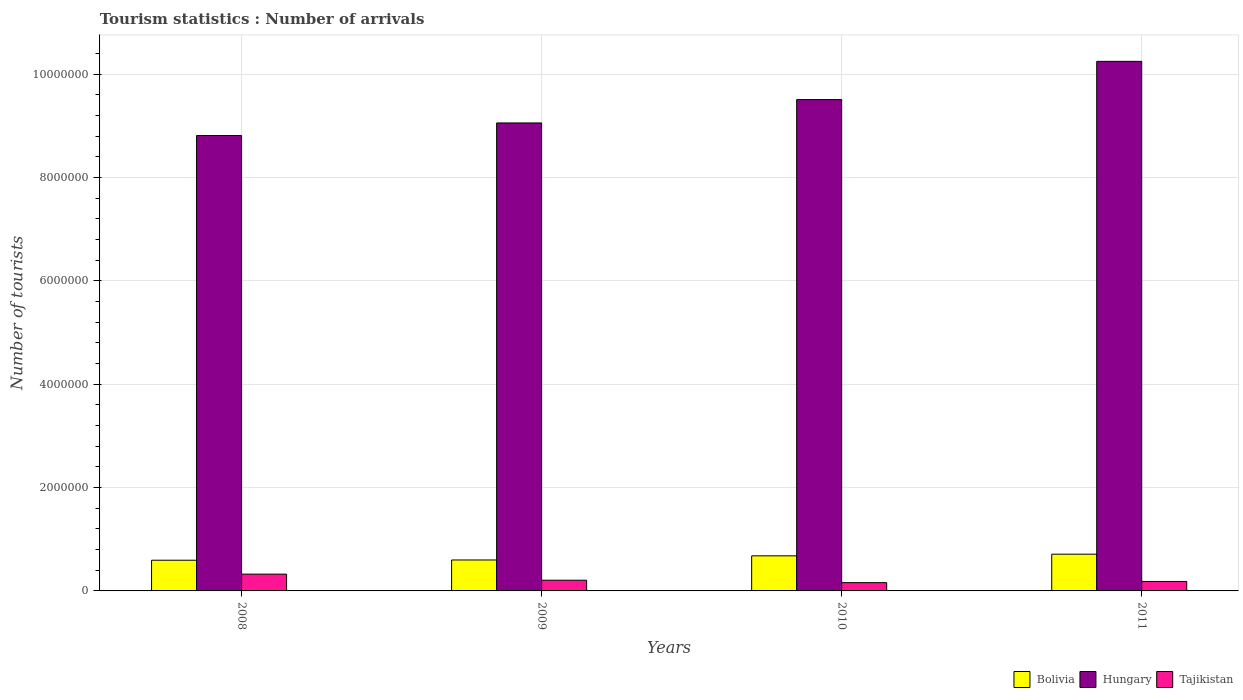How many different coloured bars are there?
Provide a short and direct response. 3. How many bars are there on the 2nd tick from the right?
Keep it short and to the point. 3. What is the label of the 4th group of bars from the left?
Offer a terse response. 2011. What is the number of tourist arrivals in Hungary in 2010?
Your answer should be compact. 9.51e+06. Across all years, what is the maximum number of tourist arrivals in Hungary?
Offer a very short reply. 1.02e+07. Across all years, what is the minimum number of tourist arrivals in Bolivia?
Offer a very short reply. 5.94e+05. In which year was the number of tourist arrivals in Bolivia minimum?
Your response must be concise. 2008. What is the total number of tourist arrivals in Tajikistan in the graph?
Keep it short and to the point. 8.75e+05. What is the difference between the number of tourist arrivals in Hungary in 2010 and that in 2011?
Provide a succinct answer. -7.40e+05. What is the difference between the number of tourist arrivals in Hungary in 2008 and the number of tourist arrivals in Bolivia in 2009?
Provide a succinct answer. 8.22e+06. What is the average number of tourist arrivals in Hungary per year?
Provide a short and direct response. 9.41e+06. In the year 2011, what is the difference between the number of tourist arrivals in Bolivia and number of tourist arrivals in Tajikistan?
Offer a terse response. 5.28e+05. What is the ratio of the number of tourist arrivals in Tajikistan in 2009 to that in 2010?
Provide a succinct answer. 1.29. What is the difference between the highest and the second highest number of tourist arrivals in Bolivia?
Offer a very short reply. 3.20e+04. What is the difference between the highest and the lowest number of tourist arrivals in Hungary?
Give a very brief answer. 1.44e+06. In how many years, is the number of tourist arrivals in Bolivia greater than the average number of tourist arrivals in Bolivia taken over all years?
Offer a very short reply. 2. Is the sum of the number of tourist arrivals in Bolivia in 2010 and 2011 greater than the maximum number of tourist arrivals in Tajikistan across all years?
Your answer should be very brief. Yes. What does the 2nd bar from the right in 2009 represents?
Offer a very short reply. Hungary. Is it the case that in every year, the sum of the number of tourist arrivals in Bolivia and number of tourist arrivals in Tajikistan is greater than the number of tourist arrivals in Hungary?
Give a very brief answer. No. How many years are there in the graph?
Your response must be concise. 4. Are the values on the major ticks of Y-axis written in scientific E-notation?
Make the answer very short. No. Does the graph contain any zero values?
Give a very brief answer. No. How are the legend labels stacked?
Your answer should be very brief. Horizontal. What is the title of the graph?
Your answer should be very brief. Tourism statistics : Number of arrivals. Does "Georgia" appear as one of the legend labels in the graph?
Provide a succinct answer. No. What is the label or title of the Y-axis?
Your answer should be very brief. Number of tourists. What is the Number of tourists of Bolivia in 2008?
Provide a short and direct response. 5.94e+05. What is the Number of tourists of Hungary in 2008?
Give a very brief answer. 8.81e+06. What is the Number of tourists of Tajikistan in 2008?
Provide a succinct answer. 3.25e+05. What is the Number of tourists of Bolivia in 2009?
Offer a very short reply. 5.99e+05. What is the Number of tourists of Hungary in 2009?
Provide a succinct answer. 9.06e+06. What is the Number of tourists in Tajikistan in 2009?
Offer a very short reply. 2.07e+05. What is the Number of tourists of Bolivia in 2010?
Make the answer very short. 6.79e+05. What is the Number of tourists of Hungary in 2010?
Give a very brief answer. 9.51e+06. What is the Number of tourists in Tajikistan in 2010?
Your answer should be compact. 1.60e+05. What is the Number of tourists in Bolivia in 2011?
Ensure brevity in your answer.  7.11e+05. What is the Number of tourists of Hungary in 2011?
Make the answer very short. 1.02e+07. What is the Number of tourists of Tajikistan in 2011?
Your answer should be very brief. 1.83e+05. Across all years, what is the maximum Number of tourists in Bolivia?
Provide a succinct answer. 7.11e+05. Across all years, what is the maximum Number of tourists of Hungary?
Keep it short and to the point. 1.02e+07. Across all years, what is the maximum Number of tourists of Tajikistan?
Ensure brevity in your answer.  3.25e+05. Across all years, what is the minimum Number of tourists in Bolivia?
Your answer should be compact. 5.94e+05. Across all years, what is the minimum Number of tourists in Hungary?
Your answer should be compact. 8.81e+06. What is the total Number of tourists of Bolivia in the graph?
Your answer should be very brief. 2.58e+06. What is the total Number of tourists in Hungary in the graph?
Offer a terse response. 3.76e+07. What is the total Number of tourists in Tajikistan in the graph?
Offer a very short reply. 8.75e+05. What is the difference between the Number of tourists in Bolivia in 2008 and that in 2009?
Keep it short and to the point. -5000. What is the difference between the Number of tourists in Hungary in 2008 and that in 2009?
Give a very brief answer. -2.44e+05. What is the difference between the Number of tourists in Tajikistan in 2008 and that in 2009?
Keep it short and to the point. 1.18e+05. What is the difference between the Number of tourists of Bolivia in 2008 and that in 2010?
Make the answer very short. -8.50e+04. What is the difference between the Number of tourists in Hungary in 2008 and that in 2010?
Offer a terse response. -6.96e+05. What is the difference between the Number of tourists in Tajikistan in 2008 and that in 2010?
Make the answer very short. 1.65e+05. What is the difference between the Number of tourists in Bolivia in 2008 and that in 2011?
Keep it short and to the point. -1.17e+05. What is the difference between the Number of tourists in Hungary in 2008 and that in 2011?
Your response must be concise. -1.44e+06. What is the difference between the Number of tourists in Tajikistan in 2008 and that in 2011?
Your response must be concise. 1.42e+05. What is the difference between the Number of tourists in Bolivia in 2009 and that in 2010?
Offer a very short reply. -8.00e+04. What is the difference between the Number of tourists in Hungary in 2009 and that in 2010?
Your answer should be compact. -4.52e+05. What is the difference between the Number of tourists of Tajikistan in 2009 and that in 2010?
Provide a succinct answer. 4.70e+04. What is the difference between the Number of tourists of Bolivia in 2009 and that in 2011?
Give a very brief answer. -1.12e+05. What is the difference between the Number of tourists in Hungary in 2009 and that in 2011?
Give a very brief answer. -1.19e+06. What is the difference between the Number of tourists in Tajikistan in 2009 and that in 2011?
Offer a very short reply. 2.40e+04. What is the difference between the Number of tourists in Bolivia in 2010 and that in 2011?
Your answer should be compact. -3.20e+04. What is the difference between the Number of tourists in Hungary in 2010 and that in 2011?
Your answer should be compact. -7.40e+05. What is the difference between the Number of tourists of Tajikistan in 2010 and that in 2011?
Your answer should be compact. -2.30e+04. What is the difference between the Number of tourists in Bolivia in 2008 and the Number of tourists in Hungary in 2009?
Your answer should be compact. -8.46e+06. What is the difference between the Number of tourists of Bolivia in 2008 and the Number of tourists of Tajikistan in 2009?
Offer a very short reply. 3.87e+05. What is the difference between the Number of tourists in Hungary in 2008 and the Number of tourists in Tajikistan in 2009?
Offer a very short reply. 8.61e+06. What is the difference between the Number of tourists of Bolivia in 2008 and the Number of tourists of Hungary in 2010?
Give a very brief answer. -8.92e+06. What is the difference between the Number of tourists of Bolivia in 2008 and the Number of tourists of Tajikistan in 2010?
Your answer should be very brief. 4.34e+05. What is the difference between the Number of tourists of Hungary in 2008 and the Number of tourists of Tajikistan in 2010?
Your answer should be very brief. 8.65e+06. What is the difference between the Number of tourists in Bolivia in 2008 and the Number of tourists in Hungary in 2011?
Your response must be concise. -9.66e+06. What is the difference between the Number of tourists in Bolivia in 2008 and the Number of tourists in Tajikistan in 2011?
Your answer should be compact. 4.11e+05. What is the difference between the Number of tourists of Hungary in 2008 and the Number of tourists of Tajikistan in 2011?
Give a very brief answer. 8.63e+06. What is the difference between the Number of tourists of Bolivia in 2009 and the Number of tourists of Hungary in 2010?
Your response must be concise. -8.91e+06. What is the difference between the Number of tourists of Bolivia in 2009 and the Number of tourists of Tajikistan in 2010?
Your response must be concise. 4.39e+05. What is the difference between the Number of tourists of Hungary in 2009 and the Number of tourists of Tajikistan in 2010?
Your answer should be very brief. 8.90e+06. What is the difference between the Number of tourists in Bolivia in 2009 and the Number of tourists in Hungary in 2011?
Provide a short and direct response. -9.65e+06. What is the difference between the Number of tourists of Bolivia in 2009 and the Number of tourists of Tajikistan in 2011?
Your response must be concise. 4.16e+05. What is the difference between the Number of tourists of Hungary in 2009 and the Number of tourists of Tajikistan in 2011?
Make the answer very short. 8.88e+06. What is the difference between the Number of tourists in Bolivia in 2010 and the Number of tourists in Hungary in 2011?
Offer a very short reply. -9.57e+06. What is the difference between the Number of tourists in Bolivia in 2010 and the Number of tourists in Tajikistan in 2011?
Your answer should be compact. 4.96e+05. What is the difference between the Number of tourists in Hungary in 2010 and the Number of tourists in Tajikistan in 2011?
Your answer should be very brief. 9.33e+06. What is the average Number of tourists in Bolivia per year?
Offer a terse response. 6.46e+05. What is the average Number of tourists of Hungary per year?
Your response must be concise. 9.41e+06. What is the average Number of tourists in Tajikistan per year?
Your response must be concise. 2.19e+05. In the year 2008, what is the difference between the Number of tourists in Bolivia and Number of tourists in Hungary?
Make the answer very short. -8.22e+06. In the year 2008, what is the difference between the Number of tourists of Bolivia and Number of tourists of Tajikistan?
Offer a terse response. 2.69e+05. In the year 2008, what is the difference between the Number of tourists of Hungary and Number of tourists of Tajikistan?
Give a very brief answer. 8.49e+06. In the year 2009, what is the difference between the Number of tourists in Bolivia and Number of tourists in Hungary?
Ensure brevity in your answer.  -8.46e+06. In the year 2009, what is the difference between the Number of tourists of Bolivia and Number of tourists of Tajikistan?
Make the answer very short. 3.92e+05. In the year 2009, what is the difference between the Number of tourists of Hungary and Number of tourists of Tajikistan?
Offer a terse response. 8.85e+06. In the year 2010, what is the difference between the Number of tourists in Bolivia and Number of tourists in Hungary?
Offer a very short reply. -8.83e+06. In the year 2010, what is the difference between the Number of tourists in Bolivia and Number of tourists in Tajikistan?
Offer a very short reply. 5.19e+05. In the year 2010, what is the difference between the Number of tourists in Hungary and Number of tourists in Tajikistan?
Your answer should be very brief. 9.35e+06. In the year 2011, what is the difference between the Number of tourists of Bolivia and Number of tourists of Hungary?
Your response must be concise. -9.54e+06. In the year 2011, what is the difference between the Number of tourists in Bolivia and Number of tourists in Tajikistan?
Offer a very short reply. 5.28e+05. In the year 2011, what is the difference between the Number of tourists in Hungary and Number of tourists in Tajikistan?
Provide a succinct answer. 1.01e+07. What is the ratio of the Number of tourists in Bolivia in 2008 to that in 2009?
Give a very brief answer. 0.99. What is the ratio of the Number of tourists in Hungary in 2008 to that in 2009?
Your response must be concise. 0.97. What is the ratio of the Number of tourists in Tajikistan in 2008 to that in 2009?
Your answer should be very brief. 1.57. What is the ratio of the Number of tourists in Bolivia in 2008 to that in 2010?
Provide a succinct answer. 0.87. What is the ratio of the Number of tourists in Hungary in 2008 to that in 2010?
Provide a short and direct response. 0.93. What is the ratio of the Number of tourists in Tajikistan in 2008 to that in 2010?
Make the answer very short. 2.03. What is the ratio of the Number of tourists in Bolivia in 2008 to that in 2011?
Offer a very short reply. 0.84. What is the ratio of the Number of tourists of Hungary in 2008 to that in 2011?
Provide a succinct answer. 0.86. What is the ratio of the Number of tourists of Tajikistan in 2008 to that in 2011?
Your answer should be compact. 1.78. What is the ratio of the Number of tourists in Bolivia in 2009 to that in 2010?
Ensure brevity in your answer.  0.88. What is the ratio of the Number of tourists in Hungary in 2009 to that in 2010?
Offer a very short reply. 0.95. What is the ratio of the Number of tourists of Tajikistan in 2009 to that in 2010?
Provide a short and direct response. 1.29. What is the ratio of the Number of tourists of Bolivia in 2009 to that in 2011?
Give a very brief answer. 0.84. What is the ratio of the Number of tourists in Hungary in 2009 to that in 2011?
Offer a terse response. 0.88. What is the ratio of the Number of tourists of Tajikistan in 2009 to that in 2011?
Provide a short and direct response. 1.13. What is the ratio of the Number of tourists of Bolivia in 2010 to that in 2011?
Offer a terse response. 0.95. What is the ratio of the Number of tourists in Hungary in 2010 to that in 2011?
Give a very brief answer. 0.93. What is the ratio of the Number of tourists of Tajikistan in 2010 to that in 2011?
Give a very brief answer. 0.87. What is the difference between the highest and the second highest Number of tourists of Bolivia?
Offer a very short reply. 3.20e+04. What is the difference between the highest and the second highest Number of tourists of Hungary?
Your answer should be compact. 7.40e+05. What is the difference between the highest and the second highest Number of tourists of Tajikistan?
Offer a terse response. 1.18e+05. What is the difference between the highest and the lowest Number of tourists of Bolivia?
Your answer should be very brief. 1.17e+05. What is the difference between the highest and the lowest Number of tourists of Hungary?
Your answer should be compact. 1.44e+06. What is the difference between the highest and the lowest Number of tourists in Tajikistan?
Your answer should be compact. 1.65e+05. 